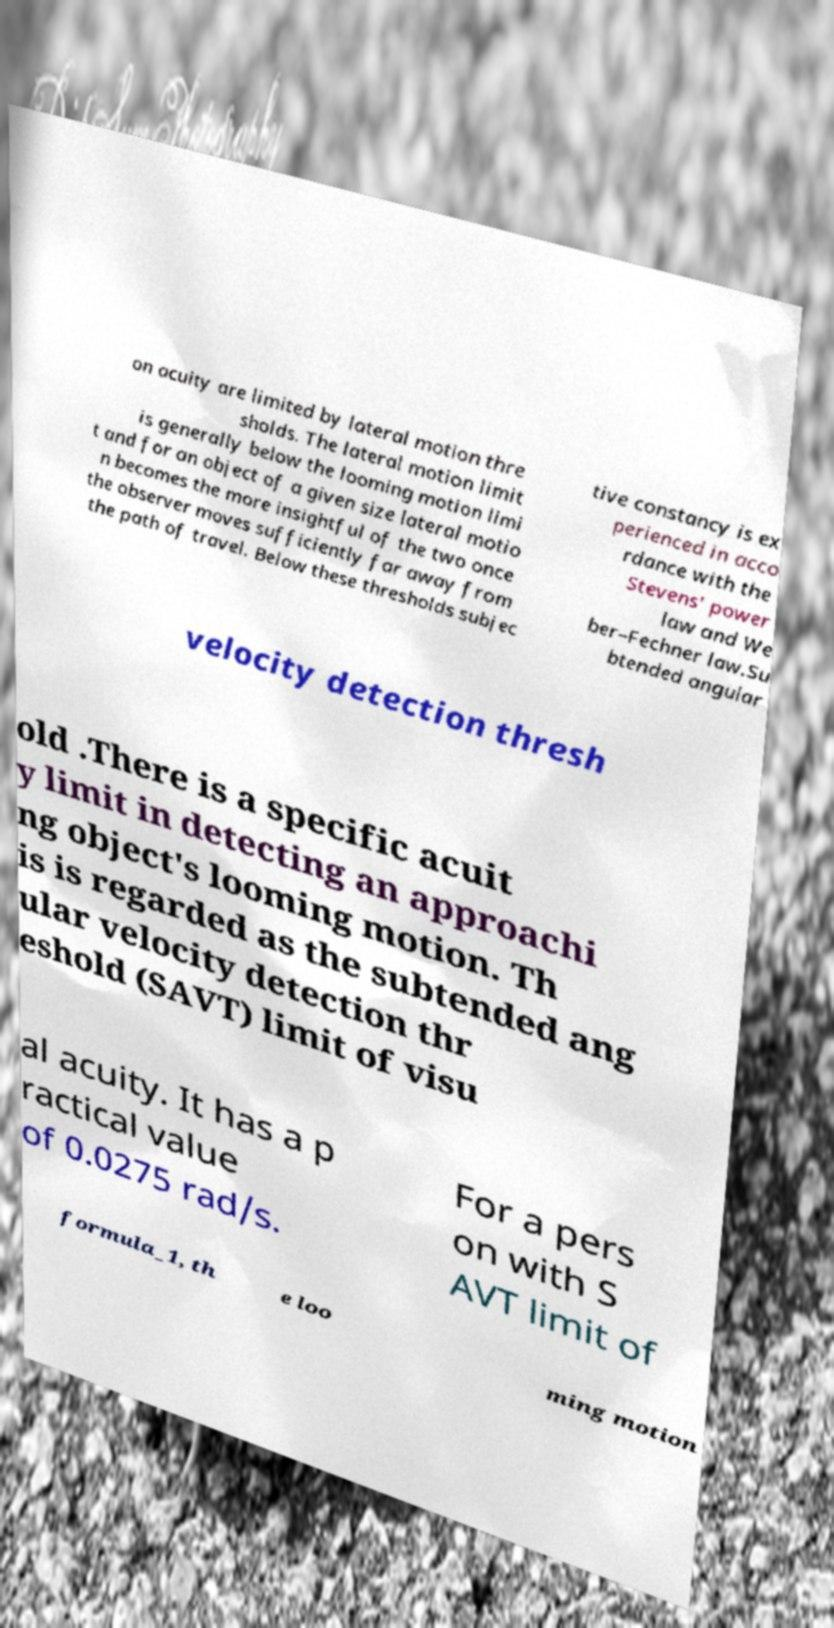Can you accurately transcribe the text from the provided image for me? on acuity are limited by lateral motion thre sholds. The lateral motion limit is generally below the looming motion limi t and for an object of a given size lateral motio n becomes the more insightful of the two once the observer moves sufficiently far away from the path of travel. Below these thresholds subjec tive constancy is ex perienced in acco rdance with the Stevens' power law and We ber–Fechner law.Su btended angular velocity detection thresh old .There is a specific acuit y limit in detecting an approachi ng object's looming motion. Th is is regarded as the subtended ang ular velocity detection thr eshold (SAVT) limit of visu al acuity. It has a p ractical value of 0.0275 rad/s. For a pers on with S AVT limit of formula_1, th e loo ming motion 